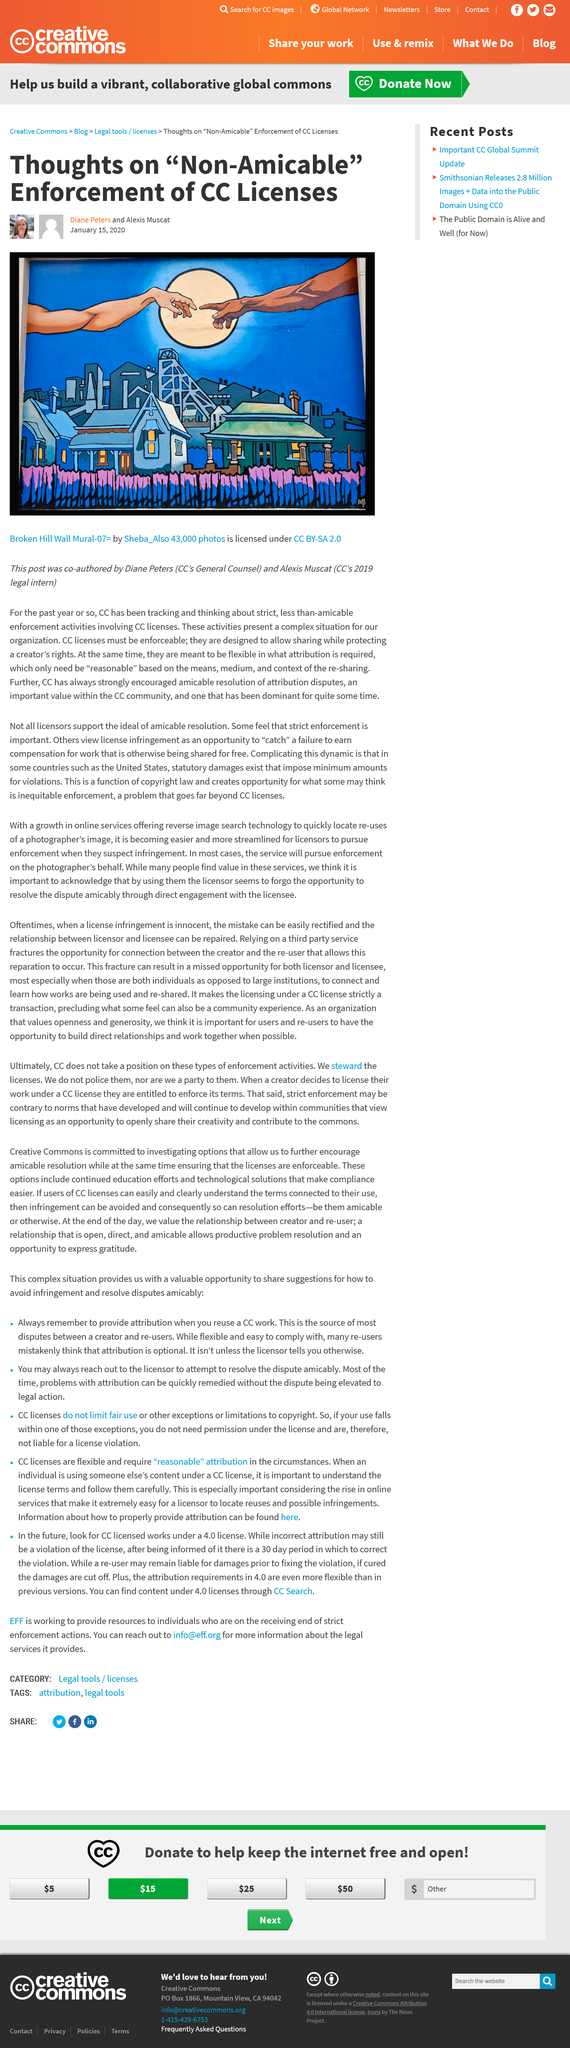Give some essential details in this illustration. Diane Peters was the General Counsel of CC in 2019. In 2019, Alexis Muscat was CC's legal intern. The title of the main image is "Broken Hill Wall Mural-07". 